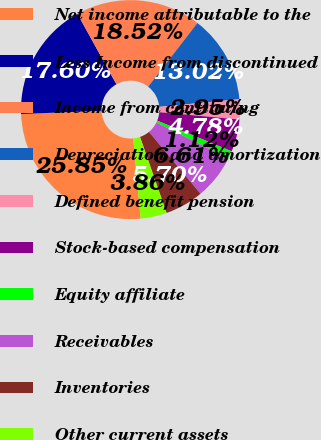<chart> <loc_0><loc_0><loc_500><loc_500><pie_chart><fcel>Net income attributable to the<fcel>Less Income from discontinued<fcel>Income from continuing<fcel>Depreciation and amortization<fcel>Defined benefit pension<fcel>Stock-based compensation<fcel>Equity affiliate<fcel>Receivables<fcel>Inventories<fcel>Other current assets<nl><fcel>25.85%<fcel>17.6%<fcel>18.52%<fcel>13.02%<fcel>2.95%<fcel>4.78%<fcel>1.12%<fcel>6.61%<fcel>5.7%<fcel>3.86%<nl></chart> 